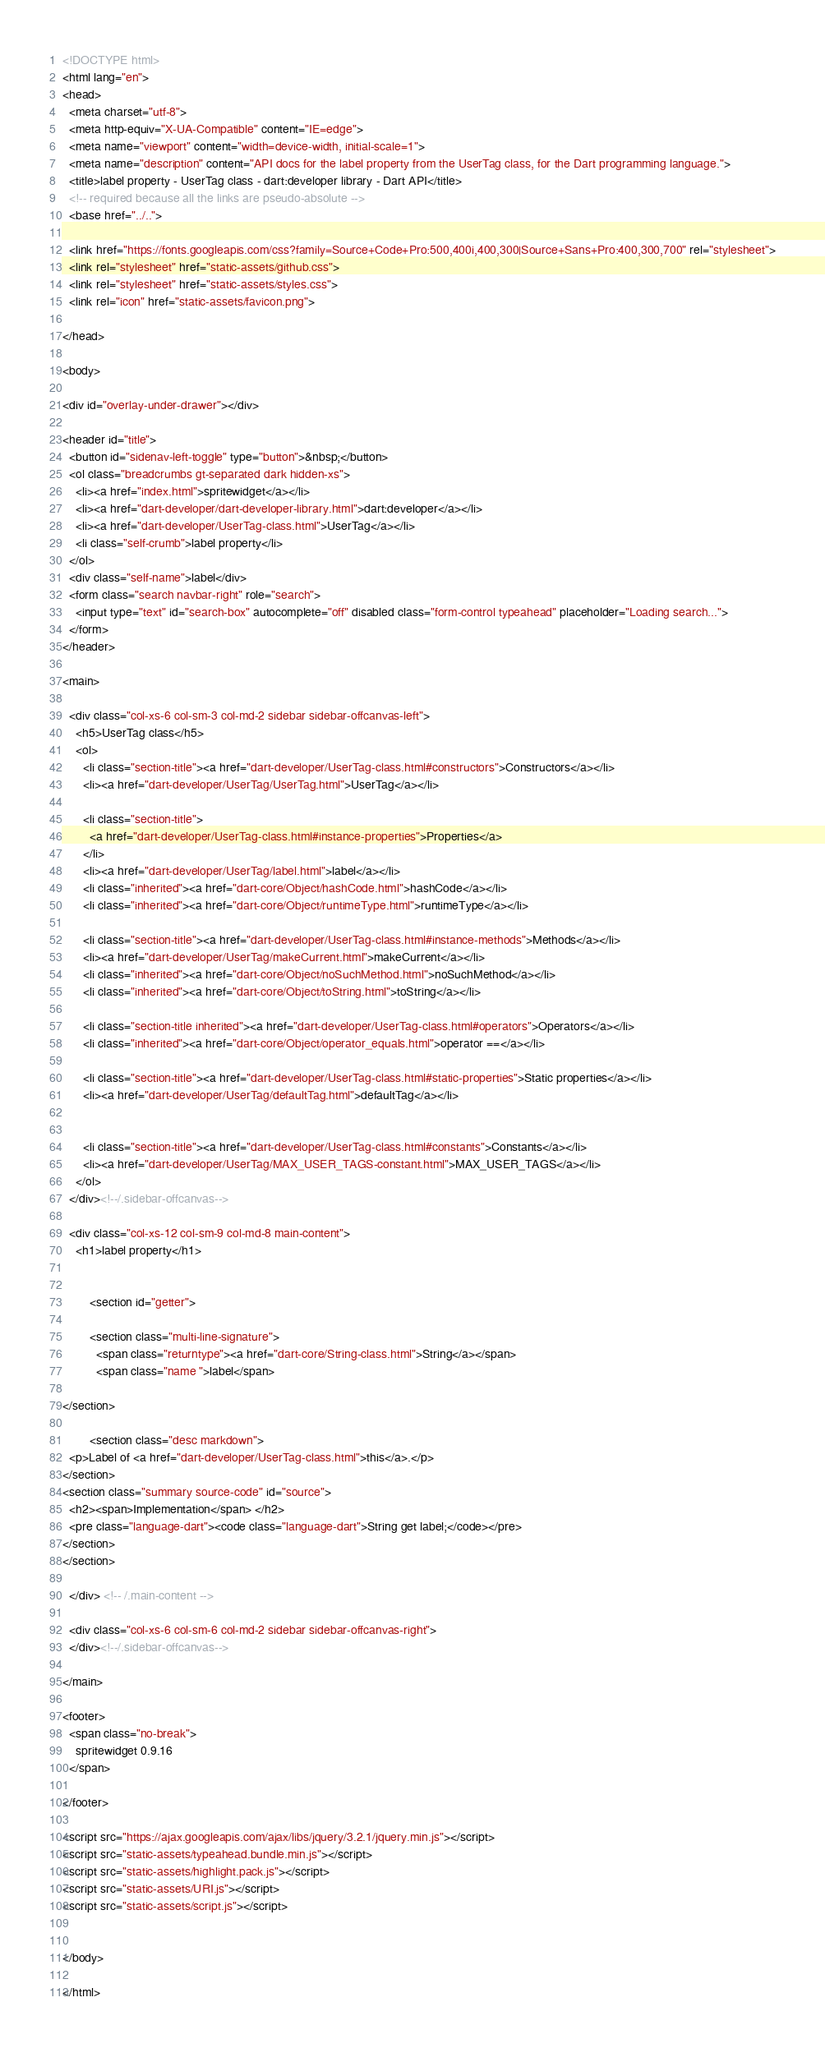Convert code to text. <code><loc_0><loc_0><loc_500><loc_500><_HTML_><!DOCTYPE html>
<html lang="en">
<head>
  <meta charset="utf-8">
  <meta http-equiv="X-UA-Compatible" content="IE=edge">
  <meta name="viewport" content="width=device-width, initial-scale=1">
  <meta name="description" content="API docs for the label property from the UserTag class, for the Dart programming language.">
  <title>label property - UserTag class - dart:developer library - Dart API</title>
  <!-- required because all the links are pseudo-absolute -->
  <base href="../..">

  <link href="https://fonts.googleapis.com/css?family=Source+Code+Pro:500,400i,400,300|Source+Sans+Pro:400,300,700" rel="stylesheet">
  <link rel="stylesheet" href="static-assets/github.css">
  <link rel="stylesheet" href="static-assets/styles.css">
  <link rel="icon" href="static-assets/favicon.png">

</head>

<body>

<div id="overlay-under-drawer"></div>

<header id="title">
  <button id="sidenav-left-toggle" type="button">&nbsp;</button>
  <ol class="breadcrumbs gt-separated dark hidden-xs">
    <li><a href="index.html">spritewidget</a></li>
    <li><a href="dart-developer/dart-developer-library.html">dart:developer</a></li>
    <li><a href="dart-developer/UserTag-class.html">UserTag</a></li>
    <li class="self-crumb">label property</li>
  </ol>
  <div class="self-name">label</div>
  <form class="search navbar-right" role="search">
    <input type="text" id="search-box" autocomplete="off" disabled class="form-control typeahead" placeholder="Loading search...">
  </form>
</header>

<main>

  <div class="col-xs-6 col-sm-3 col-md-2 sidebar sidebar-offcanvas-left">
    <h5>UserTag class</h5>
    <ol>
      <li class="section-title"><a href="dart-developer/UserTag-class.html#constructors">Constructors</a></li>
      <li><a href="dart-developer/UserTag/UserTag.html">UserTag</a></li>
    
      <li class="section-title">
        <a href="dart-developer/UserTag-class.html#instance-properties">Properties</a>
      </li>
      <li><a href="dart-developer/UserTag/label.html">label</a></li>
      <li class="inherited"><a href="dart-core/Object/hashCode.html">hashCode</a></li>
      <li class="inherited"><a href="dart-core/Object/runtimeType.html">runtimeType</a></li>
    
      <li class="section-title"><a href="dart-developer/UserTag-class.html#instance-methods">Methods</a></li>
      <li><a href="dart-developer/UserTag/makeCurrent.html">makeCurrent</a></li>
      <li class="inherited"><a href="dart-core/Object/noSuchMethod.html">noSuchMethod</a></li>
      <li class="inherited"><a href="dart-core/Object/toString.html">toString</a></li>
    
      <li class="section-title inherited"><a href="dart-developer/UserTag-class.html#operators">Operators</a></li>
      <li class="inherited"><a href="dart-core/Object/operator_equals.html">operator ==</a></li>
    
      <li class="section-title"><a href="dart-developer/UserTag-class.html#static-properties">Static properties</a></li>
      <li><a href="dart-developer/UserTag/defaultTag.html">defaultTag</a></li>
    
    
      <li class="section-title"><a href="dart-developer/UserTag-class.html#constants">Constants</a></li>
      <li><a href="dart-developer/UserTag/MAX_USER_TAGS-constant.html">MAX_USER_TAGS</a></li>
    </ol>
  </div><!--/.sidebar-offcanvas-->

  <div class="col-xs-12 col-sm-9 col-md-8 main-content">
    <h1>label property</h1>


        <section id="getter">
        
        <section class="multi-line-signature">
          <span class="returntype"><a href="dart-core/String-class.html">String</a></span>
          <span class="name ">label</span>
  
</section>
        
        <section class="desc markdown">
  <p>Label of <a href="dart-developer/UserTag-class.html">this</a>.</p>
</section>
<section class="summary source-code" id="source">
  <h2><span>Implementation</span> </h2>
  <pre class="language-dart"><code class="language-dart">String get label;</code></pre>
</section>
</section>
        
  </div> <!-- /.main-content -->

  <div class="col-xs-6 col-sm-6 col-md-2 sidebar sidebar-offcanvas-right">
  </div><!--/.sidebar-offcanvas-->

</main>

<footer>
  <span class="no-break">
    spritewidget 0.9.16
  </span>

</footer>

<script src="https://ajax.googleapis.com/ajax/libs/jquery/3.2.1/jquery.min.js"></script>
<script src="static-assets/typeahead.bundle.min.js"></script>
<script src="static-assets/highlight.pack.js"></script>
<script src="static-assets/URI.js"></script>
<script src="static-assets/script.js"></script>


</body>

</html>
</code> 